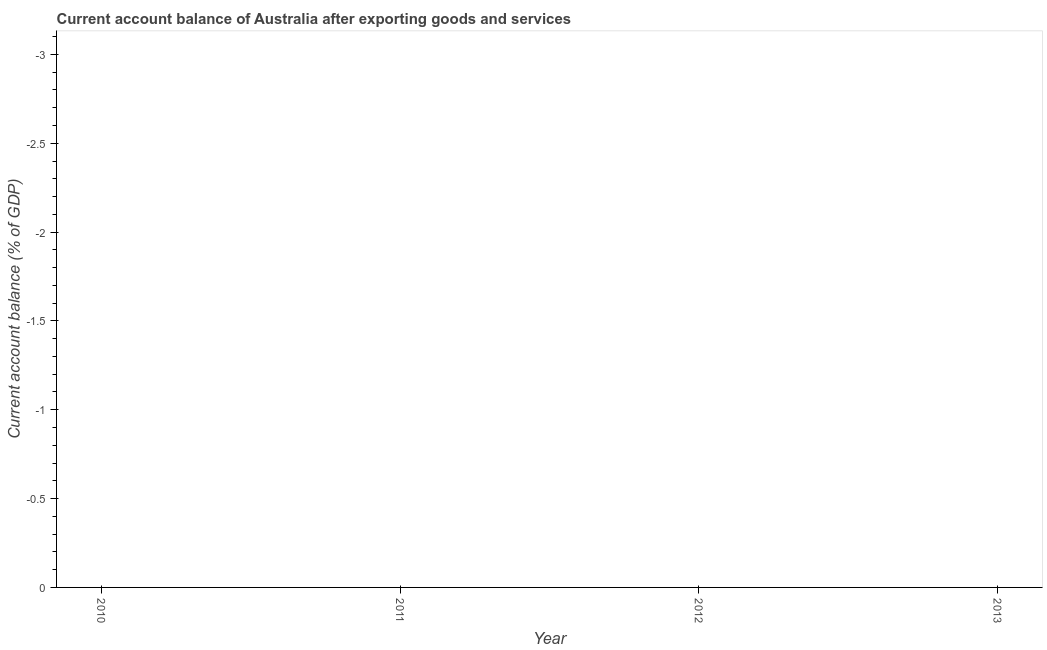What is the current account balance in 2013?
Your answer should be very brief. 0. Across all years, what is the minimum current account balance?
Provide a succinct answer. 0. Does the current account balance monotonically increase over the years?
Ensure brevity in your answer.  No. How many years are there in the graph?
Your answer should be compact. 4. What is the difference between two consecutive major ticks on the Y-axis?
Provide a short and direct response. 0.5. Are the values on the major ticks of Y-axis written in scientific E-notation?
Offer a terse response. No. What is the title of the graph?
Provide a short and direct response. Current account balance of Australia after exporting goods and services. What is the label or title of the X-axis?
Ensure brevity in your answer.  Year. What is the label or title of the Y-axis?
Offer a very short reply. Current account balance (% of GDP). What is the Current account balance (% of GDP) of 2011?
Provide a succinct answer. 0. What is the Current account balance (% of GDP) in 2013?
Offer a terse response. 0. 